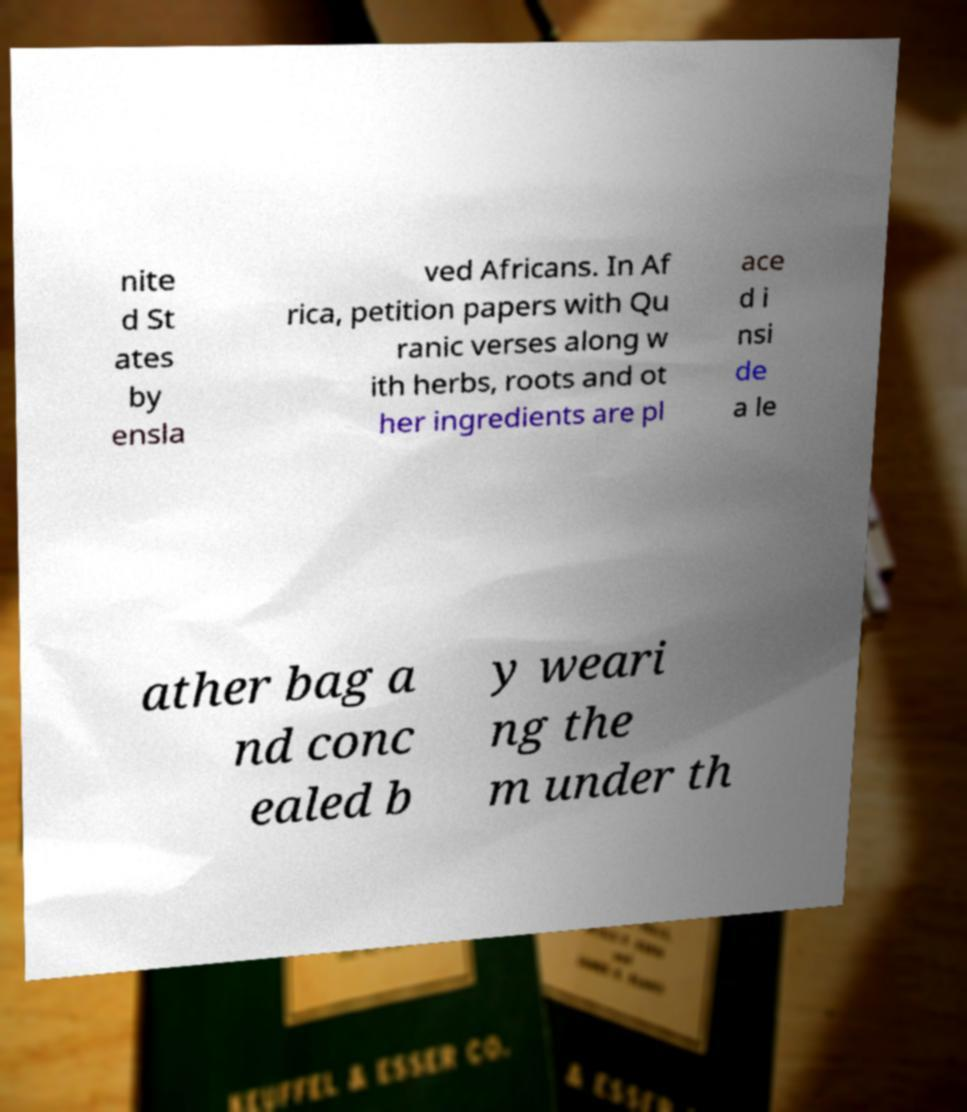Can you accurately transcribe the text from the provided image for me? nite d St ates by ensla ved Africans. In Af rica, petition papers with Qu ranic verses along w ith herbs, roots and ot her ingredients are pl ace d i nsi de a le ather bag a nd conc ealed b y weari ng the m under th 